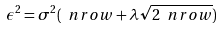<formula> <loc_0><loc_0><loc_500><loc_500>\epsilon ^ { 2 } = \sigma ^ { 2 } ( \ n r o w + \lambda \sqrt { 2 \ n r o w } )</formula> 